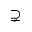<formula> <loc_0><loc_0><loc_500><loc_500>\supsetneq</formula> 